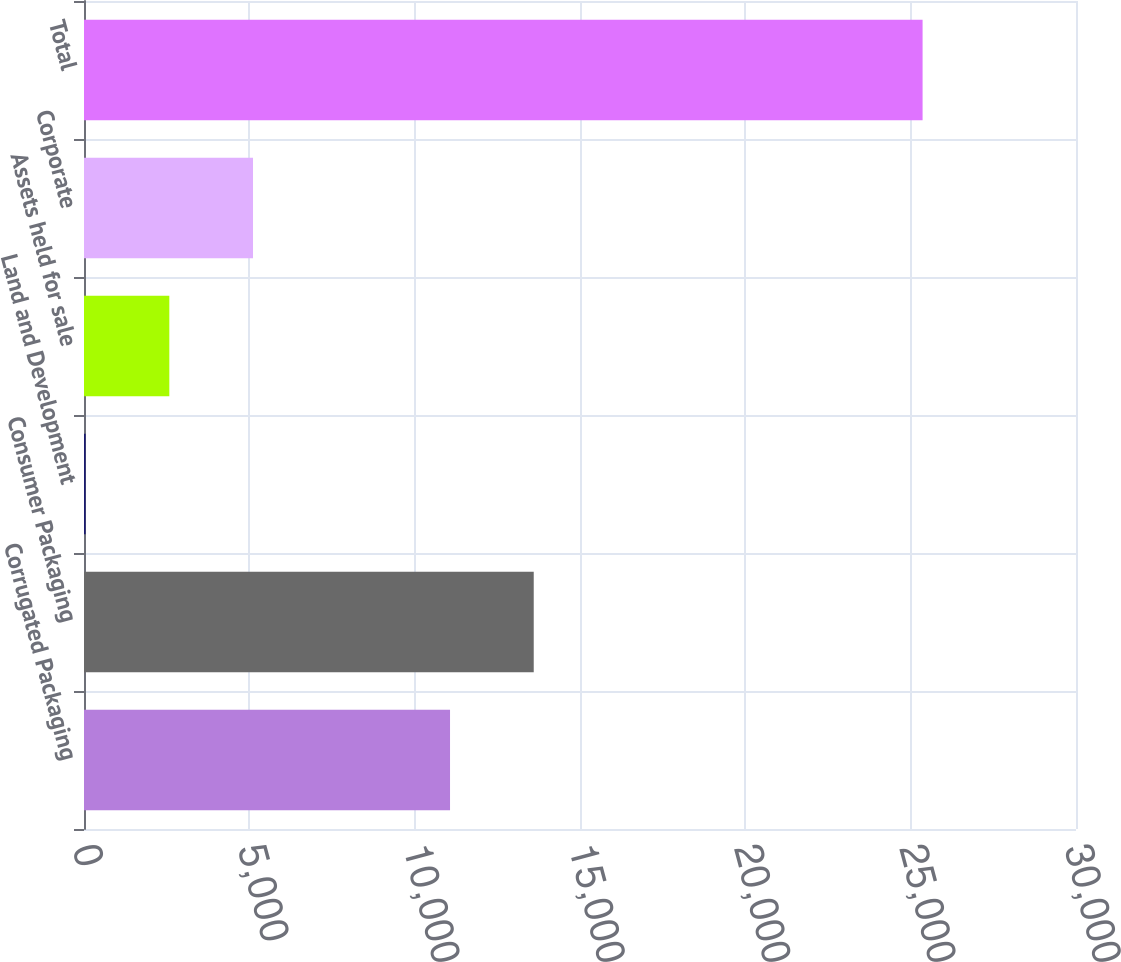Convert chart to OTSL. <chart><loc_0><loc_0><loc_500><loc_500><bar_chart><fcel>Corrugated Packaging<fcel>Consumer Packaging<fcel>Land and Development<fcel>Assets held for sale<fcel>Corporate<fcel>Total<nl><fcel>11069.6<fcel>13600.7<fcel>49.1<fcel>2580.24<fcel>5111.38<fcel>25360.5<nl></chart> 